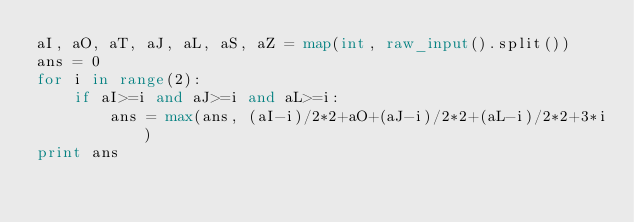Convert code to text. <code><loc_0><loc_0><loc_500><loc_500><_Python_>aI, aO, aT, aJ, aL, aS, aZ = map(int, raw_input().split())
ans = 0
for i in range(2):
    if aI>=i and aJ>=i and aL>=i:
        ans = max(ans, (aI-i)/2*2+aO+(aJ-i)/2*2+(aL-i)/2*2+3*i)
print ans
</code> 